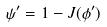<formula> <loc_0><loc_0><loc_500><loc_500>\psi ^ { \prime } = 1 - J ( \phi ^ { \prime } )</formula> 